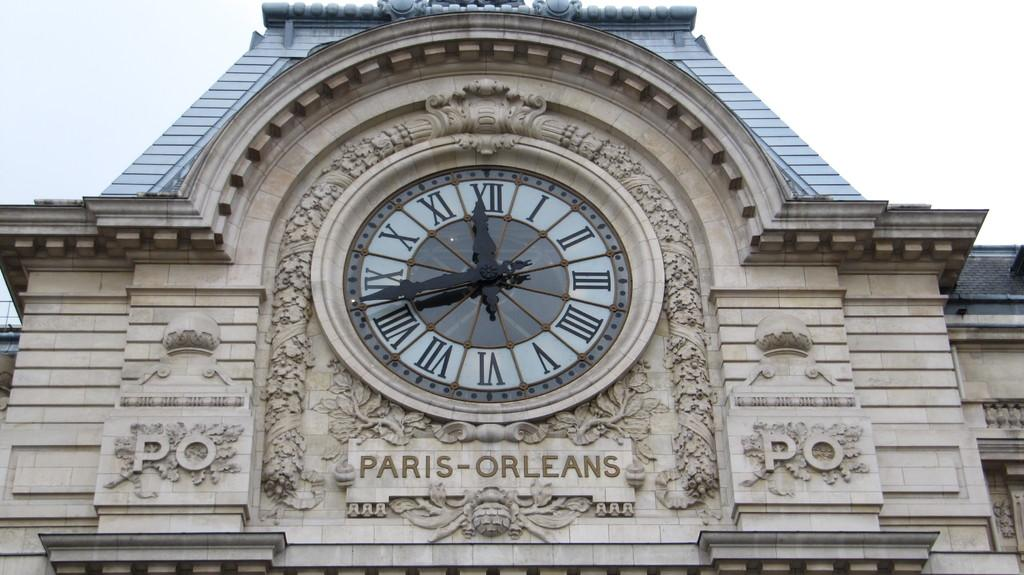Provide a one-sentence caption for the provided image. a clock outside with sign for Paris-Orleans has roman numerals. 